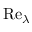Convert formula to latex. <formula><loc_0><loc_0><loc_500><loc_500>R e _ { \lambda }</formula> 